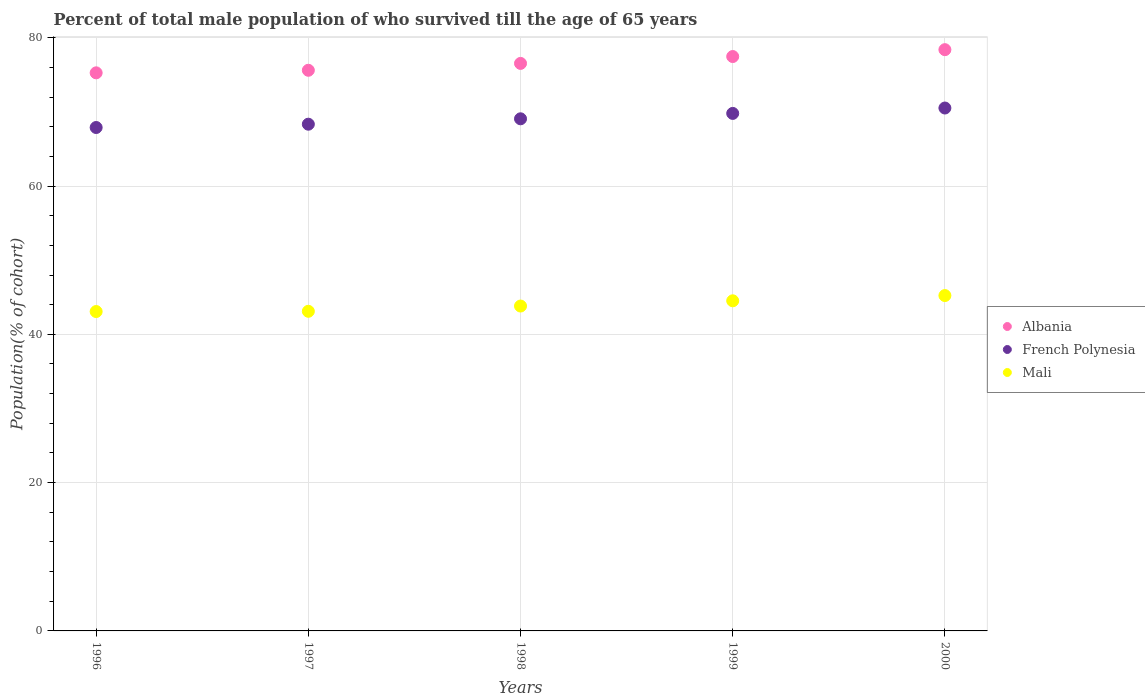How many different coloured dotlines are there?
Ensure brevity in your answer.  3. What is the percentage of total male population who survived till the age of 65 years in Albania in 1997?
Make the answer very short. 75.61. Across all years, what is the maximum percentage of total male population who survived till the age of 65 years in Mali?
Give a very brief answer. 45.23. Across all years, what is the minimum percentage of total male population who survived till the age of 65 years in Albania?
Provide a short and direct response. 75.26. In which year was the percentage of total male population who survived till the age of 65 years in Albania maximum?
Your answer should be very brief. 2000. In which year was the percentage of total male population who survived till the age of 65 years in Mali minimum?
Your answer should be compact. 1996. What is the total percentage of total male population who survived till the age of 65 years in Albania in the graph?
Your answer should be very brief. 383.27. What is the difference between the percentage of total male population who survived till the age of 65 years in Albania in 1997 and that in 1999?
Your answer should be compact. -1.85. What is the difference between the percentage of total male population who survived till the age of 65 years in Albania in 1998 and the percentage of total male population who survived till the age of 65 years in French Polynesia in 1996?
Keep it short and to the point. 8.64. What is the average percentage of total male population who survived till the age of 65 years in French Polynesia per year?
Your answer should be compact. 69.12. In the year 1998, what is the difference between the percentage of total male population who survived till the age of 65 years in Albania and percentage of total male population who survived till the age of 65 years in Mali?
Provide a succinct answer. 32.72. In how many years, is the percentage of total male population who survived till the age of 65 years in Albania greater than 56 %?
Provide a succinct answer. 5. What is the ratio of the percentage of total male population who survived till the age of 65 years in Albania in 1997 to that in 1999?
Offer a very short reply. 0.98. Is the percentage of total male population who survived till the age of 65 years in Mali in 1996 less than that in 1998?
Your response must be concise. Yes. What is the difference between the highest and the second highest percentage of total male population who survived till the age of 65 years in French Polynesia?
Provide a short and direct response. 0.73. What is the difference between the highest and the lowest percentage of total male population who survived till the age of 65 years in French Polynesia?
Keep it short and to the point. 2.63. Is it the case that in every year, the sum of the percentage of total male population who survived till the age of 65 years in Mali and percentage of total male population who survived till the age of 65 years in French Polynesia  is greater than the percentage of total male population who survived till the age of 65 years in Albania?
Your answer should be very brief. Yes. What is the difference between two consecutive major ticks on the Y-axis?
Give a very brief answer. 20. Are the values on the major ticks of Y-axis written in scientific E-notation?
Ensure brevity in your answer.  No. Where does the legend appear in the graph?
Offer a very short reply. Center right. What is the title of the graph?
Your answer should be very brief. Percent of total male population of who survived till the age of 65 years. What is the label or title of the X-axis?
Provide a short and direct response. Years. What is the label or title of the Y-axis?
Provide a short and direct response. Population(% of cohort). What is the Population(% of cohort) in Albania in 1996?
Keep it short and to the point. 75.26. What is the Population(% of cohort) of French Polynesia in 1996?
Make the answer very short. 67.89. What is the Population(% of cohort) in Mali in 1996?
Make the answer very short. 43.07. What is the Population(% of cohort) in Albania in 1997?
Give a very brief answer. 75.61. What is the Population(% of cohort) of French Polynesia in 1997?
Keep it short and to the point. 68.34. What is the Population(% of cohort) in Mali in 1997?
Ensure brevity in your answer.  43.11. What is the Population(% of cohort) of Albania in 1998?
Offer a terse response. 76.54. What is the Population(% of cohort) in French Polynesia in 1998?
Provide a succinct answer. 69.07. What is the Population(% of cohort) of Mali in 1998?
Ensure brevity in your answer.  43.81. What is the Population(% of cohort) in Albania in 1999?
Offer a terse response. 77.46. What is the Population(% of cohort) of French Polynesia in 1999?
Your response must be concise. 69.79. What is the Population(% of cohort) in Mali in 1999?
Make the answer very short. 44.52. What is the Population(% of cohort) in Albania in 2000?
Offer a very short reply. 78.39. What is the Population(% of cohort) of French Polynesia in 2000?
Provide a short and direct response. 70.52. What is the Population(% of cohort) in Mali in 2000?
Your answer should be compact. 45.23. Across all years, what is the maximum Population(% of cohort) in Albania?
Make the answer very short. 78.39. Across all years, what is the maximum Population(% of cohort) in French Polynesia?
Give a very brief answer. 70.52. Across all years, what is the maximum Population(% of cohort) in Mali?
Your response must be concise. 45.23. Across all years, what is the minimum Population(% of cohort) of Albania?
Offer a very short reply. 75.26. Across all years, what is the minimum Population(% of cohort) of French Polynesia?
Provide a short and direct response. 67.89. Across all years, what is the minimum Population(% of cohort) of Mali?
Keep it short and to the point. 43.07. What is the total Population(% of cohort) of Albania in the graph?
Keep it short and to the point. 383.27. What is the total Population(% of cohort) in French Polynesia in the graph?
Your response must be concise. 345.61. What is the total Population(% of cohort) of Mali in the graph?
Your answer should be very brief. 219.74. What is the difference between the Population(% of cohort) in Albania in 1996 and that in 1997?
Make the answer very short. -0.35. What is the difference between the Population(% of cohort) in French Polynesia in 1996 and that in 1997?
Give a very brief answer. -0.45. What is the difference between the Population(% of cohort) in Mali in 1996 and that in 1997?
Ensure brevity in your answer.  -0.03. What is the difference between the Population(% of cohort) of Albania in 1996 and that in 1998?
Give a very brief answer. -1.27. What is the difference between the Population(% of cohort) in French Polynesia in 1996 and that in 1998?
Make the answer very short. -1.17. What is the difference between the Population(% of cohort) in Mali in 1996 and that in 1998?
Ensure brevity in your answer.  -0.74. What is the difference between the Population(% of cohort) of Albania in 1996 and that in 1999?
Your response must be concise. -2.2. What is the difference between the Population(% of cohort) in French Polynesia in 1996 and that in 1999?
Offer a terse response. -1.9. What is the difference between the Population(% of cohort) of Mali in 1996 and that in 1999?
Give a very brief answer. -1.45. What is the difference between the Population(% of cohort) in Albania in 1996 and that in 2000?
Provide a succinct answer. -3.12. What is the difference between the Population(% of cohort) of French Polynesia in 1996 and that in 2000?
Keep it short and to the point. -2.63. What is the difference between the Population(% of cohort) in Mali in 1996 and that in 2000?
Give a very brief answer. -2.16. What is the difference between the Population(% of cohort) of Albania in 1997 and that in 1998?
Your answer should be compact. -0.93. What is the difference between the Population(% of cohort) in French Polynesia in 1997 and that in 1998?
Offer a terse response. -0.73. What is the difference between the Population(% of cohort) of Mali in 1997 and that in 1998?
Provide a short and direct response. -0.71. What is the difference between the Population(% of cohort) in Albania in 1997 and that in 1999?
Your response must be concise. -1.85. What is the difference between the Population(% of cohort) of French Polynesia in 1997 and that in 1999?
Give a very brief answer. -1.45. What is the difference between the Population(% of cohort) of Mali in 1997 and that in 1999?
Ensure brevity in your answer.  -1.42. What is the difference between the Population(% of cohort) of Albania in 1997 and that in 2000?
Ensure brevity in your answer.  -2.78. What is the difference between the Population(% of cohort) in French Polynesia in 1997 and that in 2000?
Offer a terse response. -2.18. What is the difference between the Population(% of cohort) of Mali in 1997 and that in 2000?
Your answer should be very brief. -2.12. What is the difference between the Population(% of cohort) in Albania in 1998 and that in 1999?
Ensure brevity in your answer.  -0.93. What is the difference between the Population(% of cohort) of French Polynesia in 1998 and that in 1999?
Give a very brief answer. -0.73. What is the difference between the Population(% of cohort) in Mali in 1998 and that in 1999?
Give a very brief answer. -0.71. What is the difference between the Population(% of cohort) of Albania in 1998 and that in 2000?
Your answer should be compact. -1.85. What is the difference between the Population(% of cohort) of French Polynesia in 1998 and that in 2000?
Ensure brevity in your answer.  -1.45. What is the difference between the Population(% of cohort) in Mali in 1998 and that in 2000?
Provide a succinct answer. -1.42. What is the difference between the Population(% of cohort) in Albania in 1999 and that in 2000?
Provide a short and direct response. -0.93. What is the difference between the Population(% of cohort) of French Polynesia in 1999 and that in 2000?
Your response must be concise. -0.73. What is the difference between the Population(% of cohort) of Mali in 1999 and that in 2000?
Offer a terse response. -0.71. What is the difference between the Population(% of cohort) of Albania in 1996 and the Population(% of cohort) of French Polynesia in 1997?
Provide a short and direct response. 6.93. What is the difference between the Population(% of cohort) in Albania in 1996 and the Population(% of cohort) in Mali in 1997?
Give a very brief answer. 32.16. What is the difference between the Population(% of cohort) of French Polynesia in 1996 and the Population(% of cohort) of Mali in 1997?
Offer a terse response. 24.79. What is the difference between the Population(% of cohort) of Albania in 1996 and the Population(% of cohort) of French Polynesia in 1998?
Give a very brief answer. 6.2. What is the difference between the Population(% of cohort) of Albania in 1996 and the Population(% of cohort) of Mali in 1998?
Ensure brevity in your answer.  31.45. What is the difference between the Population(% of cohort) in French Polynesia in 1996 and the Population(% of cohort) in Mali in 1998?
Offer a very short reply. 24.08. What is the difference between the Population(% of cohort) of Albania in 1996 and the Population(% of cohort) of French Polynesia in 1999?
Provide a short and direct response. 5.47. What is the difference between the Population(% of cohort) of Albania in 1996 and the Population(% of cohort) of Mali in 1999?
Your answer should be compact. 30.74. What is the difference between the Population(% of cohort) in French Polynesia in 1996 and the Population(% of cohort) in Mali in 1999?
Give a very brief answer. 23.37. What is the difference between the Population(% of cohort) in Albania in 1996 and the Population(% of cohort) in French Polynesia in 2000?
Ensure brevity in your answer.  4.74. What is the difference between the Population(% of cohort) of Albania in 1996 and the Population(% of cohort) of Mali in 2000?
Give a very brief answer. 30.04. What is the difference between the Population(% of cohort) in French Polynesia in 1996 and the Population(% of cohort) in Mali in 2000?
Keep it short and to the point. 22.66. What is the difference between the Population(% of cohort) of Albania in 1997 and the Population(% of cohort) of French Polynesia in 1998?
Offer a terse response. 6.54. What is the difference between the Population(% of cohort) of Albania in 1997 and the Population(% of cohort) of Mali in 1998?
Offer a very short reply. 31.8. What is the difference between the Population(% of cohort) of French Polynesia in 1997 and the Population(% of cohort) of Mali in 1998?
Offer a very short reply. 24.52. What is the difference between the Population(% of cohort) of Albania in 1997 and the Population(% of cohort) of French Polynesia in 1999?
Your answer should be compact. 5.82. What is the difference between the Population(% of cohort) of Albania in 1997 and the Population(% of cohort) of Mali in 1999?
Your response must be concise. 31.09. What is the difference between the Population(% of cohort) of French Polynesia in 1997 and the Population(% of cohort) of Mali in 1999?
Offer a very short reply. 23.82. What is the difference between the Population(% of cohort) in Albania in 1997 and the Population(% of cohort) in French Polynesia in 2000?
Your response must be concise. 5.09. What is the difference between the Population(% of cohort) of Albania in 1997 and the Population(% of cohort) of Mali in 2000?
Keep it short and to the point. 30.38. What is the difference between the Population(% of cohort) of French Polynesia in 1997 and the Population(% of cohort) of Mali in 2000?
Your answer should be very brief. 23.11. What is the difference between the Population(% of cohort) in Albania in 1998 and the Population(% of cohort) in French Polynesia in 1999?
Your response must be concise. 6.74. What is the difference between the Population(% of cohort) in Albania in 1998 and the Population(% of cohort) in Mali in 1999?
Keep it short and to the point. 32.02. What is the difference between the Population(% of cohort) of French Polynesia in 1998 and the Population(% of cohort) of Mali in 1999?
Your answer should be very brief. 24.54. What is the difference between the Population(% of cohort) of Albania in 1998 and the Population(% of cohort) of French Polynesia in 2000?
Your answer should be very brief. 6.02. What is the difference between the Population(% of cohort) in Albania in 1998 and the Population(% of cohort) in Mali in 2000?
Your answer should be compact. 31.31. What is the difference between the Population(% of cohort) in French Polynesia in 1998 and the Population(% of cohort) in Mali in 2000?
Give a very brief answer. 23.84. What is the difference between the Population(% of cohort) in Albania in 1999 and the Population(% of cohort) in French Polynesia in 2000?
Give a very brief answer. 6.94. What is the difference between the Population(% of cohort) of Albania in 1999 and the Population(% of cohort) of Mali in 2000?
Ensure brevity in your answer.  32.23. What is the difference between the Population(% of cohort) of French Polynesia in 1999 and the Population(% of cohort) of Mali in 2000?
Ensure brevity in your answer.  24.56. What is the average Population(% of cohort) of Albania per year?
Offer a very short reply. 76.65. What is the average Population(% of cohort) of French Polynesia per year?
Keep it short and to the point. 69.12. What is the average Population(% of cohort) of Mali per year?
Keep it short and to the point. 43.95. In the year 1996, what is the difference between the Population(% of cohort) in Albania and Population(% of cohort) in French Polynesia?
Give a very brief answer. 7.37. In the year 1996, what is the difference between the Population(% of cohort) in Albania and Population(% of cohort) in Mali?
Provide a succinct answer. 32.19. In the year 1996, what is the difference between the Population(% of cohort) in French Polynesia and Population(% of cohort) in Mali?
Provide a short and direct response. 24.82. In the year 1997, what is the difference between the Population(% of cohort) in Albania and Population(% of cohort) in French Polynesia?
Your answer should be compact. 7.27. In the year 1997, what is the difference between the Population(% of cohort) in Albania and Population(% of cohort) in Mali?
Offer a very short reply. 32.5. In the year 1997, what is the difference between the Population(% of cohort) in French Polynesia and Population(% of cohort) in Mali?
Ensure brevity in your answer.  25.23. In the year 1998, what is the difference between the Population(% of cohort) in Albania and Population(% of cohort) in French Polynesia?
Your answer should be very brief. 7.47. In the year 1998, what is the difference between the Population(% of cohort) in Albania and Population(% of cohort) in Mali?
Offer a terse response. 32.72. In the year 1998, what is the difference between the Population(% of cohort) in French Polynesia and Population(% of cohort) in Mali?
Make the answer very short. 25.25. In the year 1999, what is the difference between the Population(% of cohort) in Albania and Population(% of cohort) in French Polynesia?
Make the answer very short. 7.67. In the year 1999, what is the difference between the Population(% of cohort) in Albania and Population(% of cohort) in Mali?
Provide a succinct answer. 32.94. In the year 1999, what is the difference between the Population(% of cohort) of French Polynesia and Population(% of cohort) of Mali?
Offer a very short reply. 25.27. In the year 2000, what is the difference between the Population(% of cohort) of Albania and Population(% of cohort) of French Polynesia?
Give a very brief answer. 7.87. In the year 2000, what is the difference between the Population(% of cohort) in Albania and Population(% of cohort) in Mali?
Your response must be concise. 33.16. In the year 2000, what is the difference between the Population(% of cohort) in French Polynesia and Population(% of cohort) in Mali?
Offer a very short reply. 25.29. What is the ratio of the Population(% of cohort) of Albania in 1996 to that in 1997?
Your answer should be compact. 1. What is the ratio of the Population(% of cohort) of Albania in 1996 to that in 1998?
Offer a very short reply. 0.98. What is the ratio of the Population(% of cohort) of French Polynesia in 1996 to that in 1998?
Give a very brief answer. 0.98. What is the ratio of the Population(% of cohort) in Mali in 1996 to that in 1998?
Offer a very short reply. 0.98. What is the ratio of the Population(% of cohort) of Albania in 1996 to that in 1999?
Your answer should be compact. 0.97. What is the ratio of the Population(% of cohort) of French Polynesia in 1996 to that in 1999?
Provide a succinct answer. 0.97. What is the ratio of the Population(% of cohort) in Mali in 1996 to that in 1999?
Offer a very short reply. 0.97. What is the ratio of the Population(% of cohort) of Albania in 1996 to that in 2000?
Keep it short and to the point. 0.96. What is the ratio of the Population(% of cohort) in French Polynesia in 1996 to that in 2000?
Make the answer very short. 0.96. What is the ratio of the Population(% of cohort) of Mali in 1996 to that in 2000?
Your answer should be compact. 0.95. What is the ratio of the Population(% of cohort) in Albania in 1997 to that in 1998?
Keep it short and to the point. 0.99. What is the ratio of the Population(% of cohort) of French Polynesia in 1997 to that in 1998?
Ensure brevity in your answer.  0.99. What is the ratio of the Population(% of cohort) of Mali in 1997 to that in 1998?
Offer a very short reply. 0.98. What is the ratio of the Population(% of cohort) in Albania in 1997 to that in 1999?
Offer a very short reply. 0.98. What is the ratio of the Population(% of cohort) of French Polynesia in 1997 to that in 1999?
Keep it short and to the point. 0.98. What is the ratio of the Population(% of cohort) in Mali in 1997 to that in 1999?
Offer a terse response. 0.97. What is the ratio of the Population(% of cohort) in Albania in 1997 to that in 2000?
Provide a succinct answer. 0.96. What is the ratio of the Population(% of cohort) in French Polynesia in 1997 to that in 2000?
Give a very brief answer. 0.97. What is the ratio of the Population(% of cohort) in Mali in 1997 to that in 2000?
Ensure brevity in your answer.  0.95. What is the ratio of the Population(% of cohort) in Albania in 1998 to that in 1999?
Your response must be concise. 0.99. What is the ratio of the Population(% of cohort) of French Polynesia in 1998 to that in 1999?
Provide a short and direct response. 0.99. What is the ratio of the Population(% of cohort) of Mali in 1998 to that in 1999?
Offer a terse response. 0.98. What is the ratio of the Population(% of cohort) in Albania in 1998 to that in 2000?
Provide a short and direct response. 0.98. What is the ratio of the Population(% of cohort) in French Polynesia in 1998 to that in 2000?
Offer a terse response. 0.98. What is the ratio of the Population(% of cohort) of Mali in 1998 to that in 2000?
Your answer should be very brief. 0.97. What is the ratio of the Population(% of cohort) of Albania in 1999 to that in 2000?
Keep it short and to the point. 0.99. What is the ratio of the Population(% of cohort) of Mali in 1999 to that in 2000?
Keep it short and to the point. 0.98. What is the difference between the highest and the second highest Population(% of cohort) in Albania?
Your answer should be very brief. 0.93. What is the difference between the highest and the second highest Population(% of cohort) in French Polynesia?
Give a very brief answer. 0.73. What is the difference between the highest and the second highest Population(% of cohort) of Mali?
Provide a short and direct response. 0.71. What is the difference between the highest and the lowest Population(% of cohort) of Albania?
Give a very brief answer. 3.12. What is the difference between the highest and the lowest Population(% of cohort) of French Polynesia?
Provide a short and direct response. 2.63. What is the difference between the highest and the lowest Population(% of cohort) of Mali?
Make the answer very short. 2.16. 